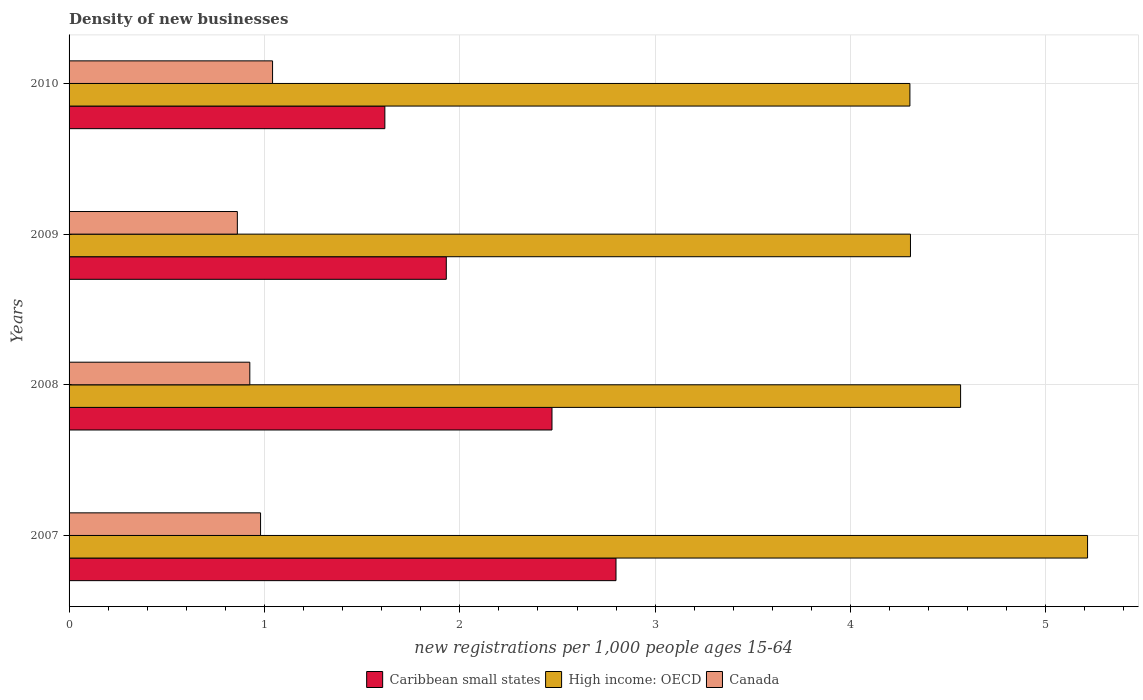How many different coloured bars are there?
Keep it short and to the point. 3. How many bars are there on the 1st tick from the bottom?
Keep it short and to the point. 3. In how many cases, is the number of bars for a given year not equal to the number of legend labels?
Ensure brevity in your answer.  0. What is the number of new registrations in High income: OECD in 2007?
Ensure brevity in your answer.  5.21. Across all years, what is the maximum number of new registrations in Canada?
Make the answer very short. 1.04. Across all years, what is the minimum number of new registrations in High income: OECD?
Provide a short and direct response. 4.3. In which year was the number of new registrations in Caribbean small states minimum?
Make the answer very short. 2010. What is the total number of new registrations in Caribbean small states in the graph?
Your answer should be compact. 8.82. What is the difference between the number of new registrations in Canada in 2008 and that in 2010?
Offer a terse response. -0.12. What is the difference between the number of new registrations in High income: OECD in 2010 and the number of new registrations in Caribbean small states in 2009?
Provide a succinct answer. 2.37. What is the average number of new registrations in High income: OECD per year?
Offer a very short reply. 4.6. In the year 2008, what is the difference between the number of new registrations in Canada and number of new registrations in Caribbean small states?
Your answer should be compact. -1.55. In how many years, is the number of new registrations in Caribbean small states greater than 3.2 ?
Provide a short and direct response. 0. What is the ratio of the number of new registrations in Canada in 2007 to that in 2008?
Your response must be concise. 1.06. Is the number of new registrations in High income: OECD in 2008 less than that in 2010?
Your answer should be very brief. No. Is the difference between the number of new registrations in Canada in 2008 and 2009 greater than the difference between the number of new registrations in Caribbean small states in 2008 and 2009?
Give a very brief answer. No. What is the difference between the highest and the second highest number of new registrations in High income: OECD?
Make the answer very short. 0.65. What is the difference between the highest and the lowest number of new registrations in Caribbean small states?
Your answer should be very brief. 1.18. In how many years, is the number of new registrations in Canada greater than the average number of new registrations in Canada taken over all years?
Ensure brevity in your answer.  2. What does the 2nd bar from the bottom in 2009 represents?
Provide a short and direct response. High income: OECD. Is it the case that in every year, the sum of the number of new registrations in Caribbean small states and number of new registrations in Canada is greater than the number of new registrations in High income: OECD?
Your response must be concise. No. What is the difference between two consecutive major ticks on the X-axis?
Your answer should be very brief. 1. Are the values on the major ticks of X-axis written in scientific E-notation?
Offer a terse response. No. Does the graph contain any zero values?
Give a very brief answer. No. Does the graph contain grids?
Your answer should be compact. Yes. How are the legend labels stacked?
Offer a terse response. Horizontal. What is the title of the graph?
Your answer should be very brief. Density of new businesses. What is the label or title of the X-axis?
Your answer should be compact. New registrations per 1,0 people ages 15-64. What is the new registrations per 1,000 people ages 15-64 of Caribbean small states in 2007?
Your response must be concise. 2.8. What is the new registrations per 1,000 people ages 15-64 of High income: OECD in 2007?
Keep it short and to the point. 5.21. What is the new registrations per 1,000 people ages 15-64 of Canada in 2007?
Provide a succinct answer. 0.98. What is the new registrations per 1,000 people ages 15-64 of Caribbean small states in 2008?
Offer a very short reply. 2.47. What is the new registrations per 1,000 people ages 15-64 in High income: OECD in 2008?
Your response must be concise. 4.56. What is the new registrations per 1,000 people ages 15-64 of Canada in 2008?
Make the answer very short. 0.93. What is the new registrations per 1,000 people ages 15-64 in Caribbean small states in 2009?
Your answer should be compact. 1.93. What is the new registrations per 1,000 people ages 15-64 in High income: OECD in 2009?
Your answer should be very brief. 4.31. What is the new registrations per 1,000 people ages 15-64 in Canada in 2009?
Your answer should be compact. 0.86. What is the new registrations per 1,000 people ages 15-64 in Caribbean small states in 2010?
Make the answer very short. 1.62. What is the new registrations per 1,000 people ages 15-64 in High income: OECD in 2010?
Give a very brief answer. 4.3. What is the new registrations per 1,000 people ages 15-64 of Canada in 2010?
Provide a succinct answer. 1.04. Across all years, what is the maximum new registrations per 1,000 people ages 15-64 of Caribbean small states?
Ensure brevity in your answer.  2.8. Across all years, what is the maximum new registrations per 1,000 people ages 15-64 of High income: OECD?
Your response must be concise. 5.21. Across all years, what is the maximum new registrations per 1,000 people ages 15-64 of Canada?
Provide a short and direct response. 1.04. Across all years, what is the minimum new registrations per 1,000 people ages 15-64 in Caribbean small states?
Offer a very short reply. 1.62. Across all years, what is the minimum new registrations per 1,000 people ages 15-64 of High income: OECD?
Make the answer very short. 4.3. Across all years, what is the minimum new registrations per 1,000 people ages 15-64 in Canada?
Provide a short and direct response. 0.86. What is the total new registrations per 1,000 people ages 15-64 in Caribbean small states in the graph?
Your answer should be compact. 8.82. What is the total new registrations per 1,000 people ages 15-64 of High income: OECD in the graph?
Ensure brevity in your answer.  18.39. What is the total new registrations per 1,000 people ages 15-64 of Canada in the graph?
Provide a short and direct response. 3.81. What is the difference between the new registrations per 1,000 people ages 15-64 of Caribbean small states in 2007 and that in 2008?
Give a very brief answer. 0.33. What is the difference between the new registrations per 1,000 people ages 15-64 in High income: OECD in 2007 and that in 2008?
Offer a terse response. 0.65. What is the difference between the new registrations per 1,000 people ages 15-64 of Canada in 2007 and that in 2008?
Give a very brief answer. 0.06. What is the difference between the new registrations per 1,000 people ages 15-64 in Caribbean small states in 2007 and that in 2009?
Your answer should be very brief. 0.87. What is the difference between the new registrations per 1,000 people ages 15-64 in High income: OECD in 2007 and that in 2009?
Offer a very short reply. 0.91. What is the difference between the new registrations per 1,000 people ages 15-64 of Canada in 2007 and that in 2009?
Provide a succinct answer. 0.12. What is the difference between the new registrations per 1,000 people ages 15-64 of Caribbean small states in 2007 and that in 2010?
Your response must be concise. 1.18. What is the difference between the new registrations per 1,000 people ages 15-64 in High income: OECD in 2007 and that in 2010?
Make the answer very short. 0.91. What is the difference between the new registrations per 1,000 people ages 15-64 in Canada in 2007 and that in 2010?
Offer a very short reply. -0.06. What is the difference between the new registrations per 1,000 people ages 15-64 of Caribbean small states in 2008 and that in 2009?
Offer a very short reply. 0.54. What is the difference between the new registrations per 1,000 people ages 15-64 in High income: OECD in 2008 and that in 2009?
Ensure brevity in your answer.  0.26. What is the difference between the new registrations per 1,000 people ages 15-64 in Canada in 2008 and that in 2009?
Ensure brevity in your answer.  0.06. What is the difference between the new registrations per 1,000 people ages 15-64 in Caribbean small states in 2008 and that in 2010?
Offer a terse response. 0.86. What is the difference between the new registrations per 1,000 people ages 15-64 in High income: OECD in 2008 and that in 2010?
Provide a succinct answer. 0.26. What is the difference between the new registrations per 1,000 people ages 15-64 in Canada in 2008 and that in 2010?
Keep it short and to the point. -0.12. What is the difference between the new registrations per 1,000 people ages 15-64 in Caribbean small states in 2009 and that in 2010?
Your answer should be very brief. 0.31. What is the difference between the new registrations per 1,000 people ages 15-64 of High income: OECD in 2009 and that in 2010?
Your answer should be compact. 0. What is the difference between the new registrations per 1,000 people ages 15-64 of Canada in 2009 and that in 2010?
Your answer should be compact. -0.18. What is the difference between the new registrations per 1,000 people ages 15-64 of Caribbean small states in 2007 and the new registrations per 1,000 people ages 15-64 of High income: OECD in 2008?
Your answer should be compact. -1.76. What is the difference between the new registrations per 1,000 people ages 15-64 in Caribbean small states in 2007 and the new registrations per 1,000 people ages 15-64 in Canada in 2008?
Make the answer very short. 1.87. What is the difference between the new registrations per 1,000 people ages 15-64 of High income: OECD in 2007 and the new registrations per 1,000 people ages 15-64 of Canada in 2008?
Provide a short and direct response. 4.29. What is the difference between the new registrations per 1,000 people ages 15-64 of Caribbean small states in 2007 and the new registrations per 1,000 people ages 15-64 of High income: OECD in 2009?
Your response must be concise. -1.51. What is the difference between the new registrations per 1,000 people ages 15-64 in Caribbean small states in 2007 and the new registrations per 1,000 people ages 15-64 in Canada in 2009?
Provide a succinct answer. 1.94. What is the difference between the new registrations per 1,000 people ages 15-64 of High income: OECD in 2007 and the new registrations per 1,000 people ages 15-64 of Canada in 2009?
Ensure brevity in your answer.  4.35. What is the difference between the new registrations per 1,000 people ages 15-64 in Caribbean small states in 2007 and the new registrations per 1,000 people ages 15-64 in High income: OECD in 2010?
Offer a terse response. -1.5. What is the difference between the new registrations per 1,000 people ages 15-64 in Caribbean small states in 2007 and the new registrations per 1,000 people ages 15-64 in Canada in 2010?
Give a very brief answer. 1.76. What is the difference between the new registrations per 1,000 people ages 15-64 of High income: OECD in 2007 and the new registrations per 1,000 people ages 15-64 of Canada in 2010?
Your answer should be compact. 4.17. What is the difference between the new registrations per 1,000 people ages 15-64 of Caribbean small states in 2008 and the new registrations per 1,000 people ages 15-64 of High income: OECD in 2009?
Your answer should be compact. -1.84. What is the difference between the new registrations per 1,000 people ages 15-64 in Caribbean small states in 2008 and the new registrations per 1,000 people ages 15-64 in Canada in 2009?
Your answer should be very brief. 1.61. What is the difference between the new registrations per 1,000 people ages 15-64 of High income: OECD in 2008 and the new registrations per 1,000 people ages 15-64 of Canada in 2009?
Make the answer very short. 3.7. What is the difference between the new registrations per 1,000 people ages 15-64 in Caribbean small states in 2008 and the new registrations per 1,000 people ages 15-64 in High income: OECD in 2010?
Ensure brevity in your answer.  -1.83. What is the difference between the new registrations per 1,000 people ages 15-64 in Caribbean small states in 2008 and the new registrations per 1,000 people ages 15-64 in Canada in 2010?
Ensure brevity in your answer.  1.43. What is the difference between the new registrations per 1,000 people ages 15-64 in High income: OECD in 2008 and the new registrations per 1,000 people ages 15-64 in Canada in 2010?
Offer a very short reply. 3.52. What is the difference between the new registrations per 1,000 people ages 15-64 in Caribbean small states in 2009 and the new registrations per 1,000 people ages 15-64 in High income: OECD in 2010?
Provide a succinct answer. -2.37. What is the difference between the new registrations per 1,000 people ages 15-64 of Caribbean small states in 2009 and the new registrations per 1,000 people ages 15-64 of Canada in 2010?
Your response must be concise. 0.89. What is the difference between the new registrations per 1,000 people ages 15-64 of High income: OECD in 2009 and the new registrations per 1,000 people ages 15-64 of Canada in 2010?
Provide a short and direct response. 3.27. What is the average new registrations per 1,000 people ages 15-64 in Caribbean small states per year?
Your response must be concise. 2.2. What is the average new registrations per 1,000 people ages 15-64 of High income: OECD per year?
Offer a terse response. 4.6. What is the average new registrations per 1,000 people ages 15-64 of Canada per year?
Give a very brief answer. 0.95. In the year 2007, what is the difference between the new registrations per 1,000 people ages 15-64 in Caribbean small states and new registrations per 1,000 people ages 15-64 in High income: OECD?
Your response must be concise. -2.41. In the year 2007, what is the difference between the new registrations per 1,000 people ages 15-64 of Caribbean small states and new registrations per 1,000 people ages 15-64 of Canada?
Your answer should be compact. 1.82. In the year 2007, what is the difference between the new registrations per 1,000 people ages 15-64 in High income: OECD and new registrations per 1,000 people ages 15-64 in Canada?
Offer a terse response. 4.23. In the year 2008, what is the difference between the new registrations per 1,000 people ages 15-64 in Caribbean small states and new registrations per 1,000 people ages 15-64 in High income: OECD?
Your answer should be compact. -2.09. In the year 2008, what is the difference between the new registrations per 1,000 people ages 15-64 of Caribbean small states and new registrations per 1,000 people ages 15-64 of Canada?
Offer a very short reply. 1.55. In the year 2008, what is the difference between the new registrations per 1,000 people ages 15-64 in High income: OECD and new registrations per 1,000 people ages 15-64 in Canada?
Offer a very short reply. 3.64. In the year 2009, what is the difference between the new registrations per 1,000 people ages 15-64 of Caribbean small states and new registrations per 1,000 people ages 15-64 of High income: OECD?
Provide a short and direct response. -2.38. In the year 2009, what is the difference between the new registrations per 1,000 people ages 15-64 of Caribbean small states and new registrations per 1,000 people ages 15-64 of Canada?
Your answer should be very brief. 1.07. In the year 2009, what is the difference between the new registrations per 1,000 people ages 15-64 in High income: OECD and new registrations per 1,000 people ages 15-64 in Canada?
Your answer should be compact. 3.45. In the year 2010, what is the difference between the new registrations per 1,000 people ages 15-64 of Caribbean small states and new registrations per 1,000 people ages 15-64 of High income: OECD?
Ensure brevity in your answer.  -2.69. In the year 2010, what is the difference between the new registrations per 1,000 people ages 15-64 of Caribbean small states and new registrations per 1,000 people ages 15-64 of Canada?
Offer a terse response. 0.57. In the year 2010, what is the difference between the new registrations per 1,000 people ages 15-64 in High income: OECD and new registrations per 1,000 people ages 15-64 in Canada?
Offer a very short reply. 3.26. What is the ratio of the new registrations per 1,000 people ages 15-64 of Caribbean small states in 2007 to that in 2008?
Offer a very short reply. 1.13. What is the ratio of the new registrations per 1,000 people ages 15-64 of High income: OECD in 2007 to that in 2008?
Keep it short and to the point. 1.14. What is the ratio of the new registrations per 1,000 people ages 15-64 in Canada in 2007 to that in 2008?
Make the answer very short. 1.06. What is the ratio of the new registrations per 1,000 people ages 15-64 of Caribbean small states in 2007 to that in 2009?
Provide a succinct answer. 1.45. What is the ratio of the new registrations per 1,000 people ages 15-64 of High income: OECD in 2007 to that in 2009?
Offer a terse response. 1.21. What is the ratio of the new registrations per 1,000 people ages 15-64 of Canada in 2007 to that in 2009?
Provide a succinct answer. 1.14. What is the ratio of the new registrations per 1,000 people ages 15-64 of Caribbean small states in 2007 to that in 2010?
Your response must be concise. 1.73. What is the ratio of the new registrations per 1,000 people ages 15-64 of High income: OECD in 2007 to that in 2010?
Give a very brief answer. 1.21. What is the ratio of the new registrations per 1,000 people ages 15-64 in Canada in 2007 to that in 2010?
Keep it short and to the point. 0.94. What is the ratio of the new registrations per 1,000 people ages 15-64 in Caribbean small states in 2008 to that in 2009?
Your answer should be very brief. 1.28. What is the ratio of the new registrations per 1,000 people ages 15-64 of High income: OECD in 2008 to that in 2009?
Keep it short and to the point. 1.06. What is the ratio of the new registrations per 1,000 people ages 15-64 in Canada in 2008 to that in 2009?
Ensure brevity in your answer.  1.07. What is the ratio of the new registrations per 1,000 people ages 15-64 of Caribbean small states in 2008 to that in 2010?
Make the answer very short. 1.53. What is the ratio of the new registrations per 1,000 people ages 15-64 of High income: OECD in 2008 to that in 2010?
Give a very brief answer. 1.06. What is the ratio of the new registrations per 1,000 people ages 15-64 in Canada in 2008 to that in 2010?
Offer a terse response. 0.89. What is the ratio of the new registrations per 1,000 people ages 15-64 in Caribbean small states in 2009 to that in 2010?
Provide a short and direct response. 1.19. What is the ratio of the new registrations per 1,000 people ages 15-64 in High income: OECD in 2009 to that in 2010?
Keep it short and to the point. 1. What is the ratio of the new registrations per 1,000 people ages 15-64 in Canada in 2009 to that in 2010?
Keep it short and to the point. 0.83. What is the difference between the highest and the second highest new registrations per 1,000 people ages 15-64 of Caribbean small states?
Provide a short and direct response. 0.33. What is the difference between the highest and the second highest new registrations per 1,000 people ages 15-64 of High income: OECD?
Offer a very short reply. 0.65. What is the difference between the highest and the second highest new registrations per 1,000 people ages 15-64 in Canada?
Your answer should be compact. 0.06. What is the difference between the highest and the lowest new registrations per 1,000 people ages 15-64 in Caribbean small states?
Your answer should be very brief. 1.18. What is the difference between the highest and the lowest new registrations per 1,000 people ages 15-64 in High income: OECD?
Ensure brevity in your answer.  0.91. What is the difference between the highest and the lowest new registrations per 1,000 people ages 15-64 in Canada?
Make the answer very short. 0.18. 